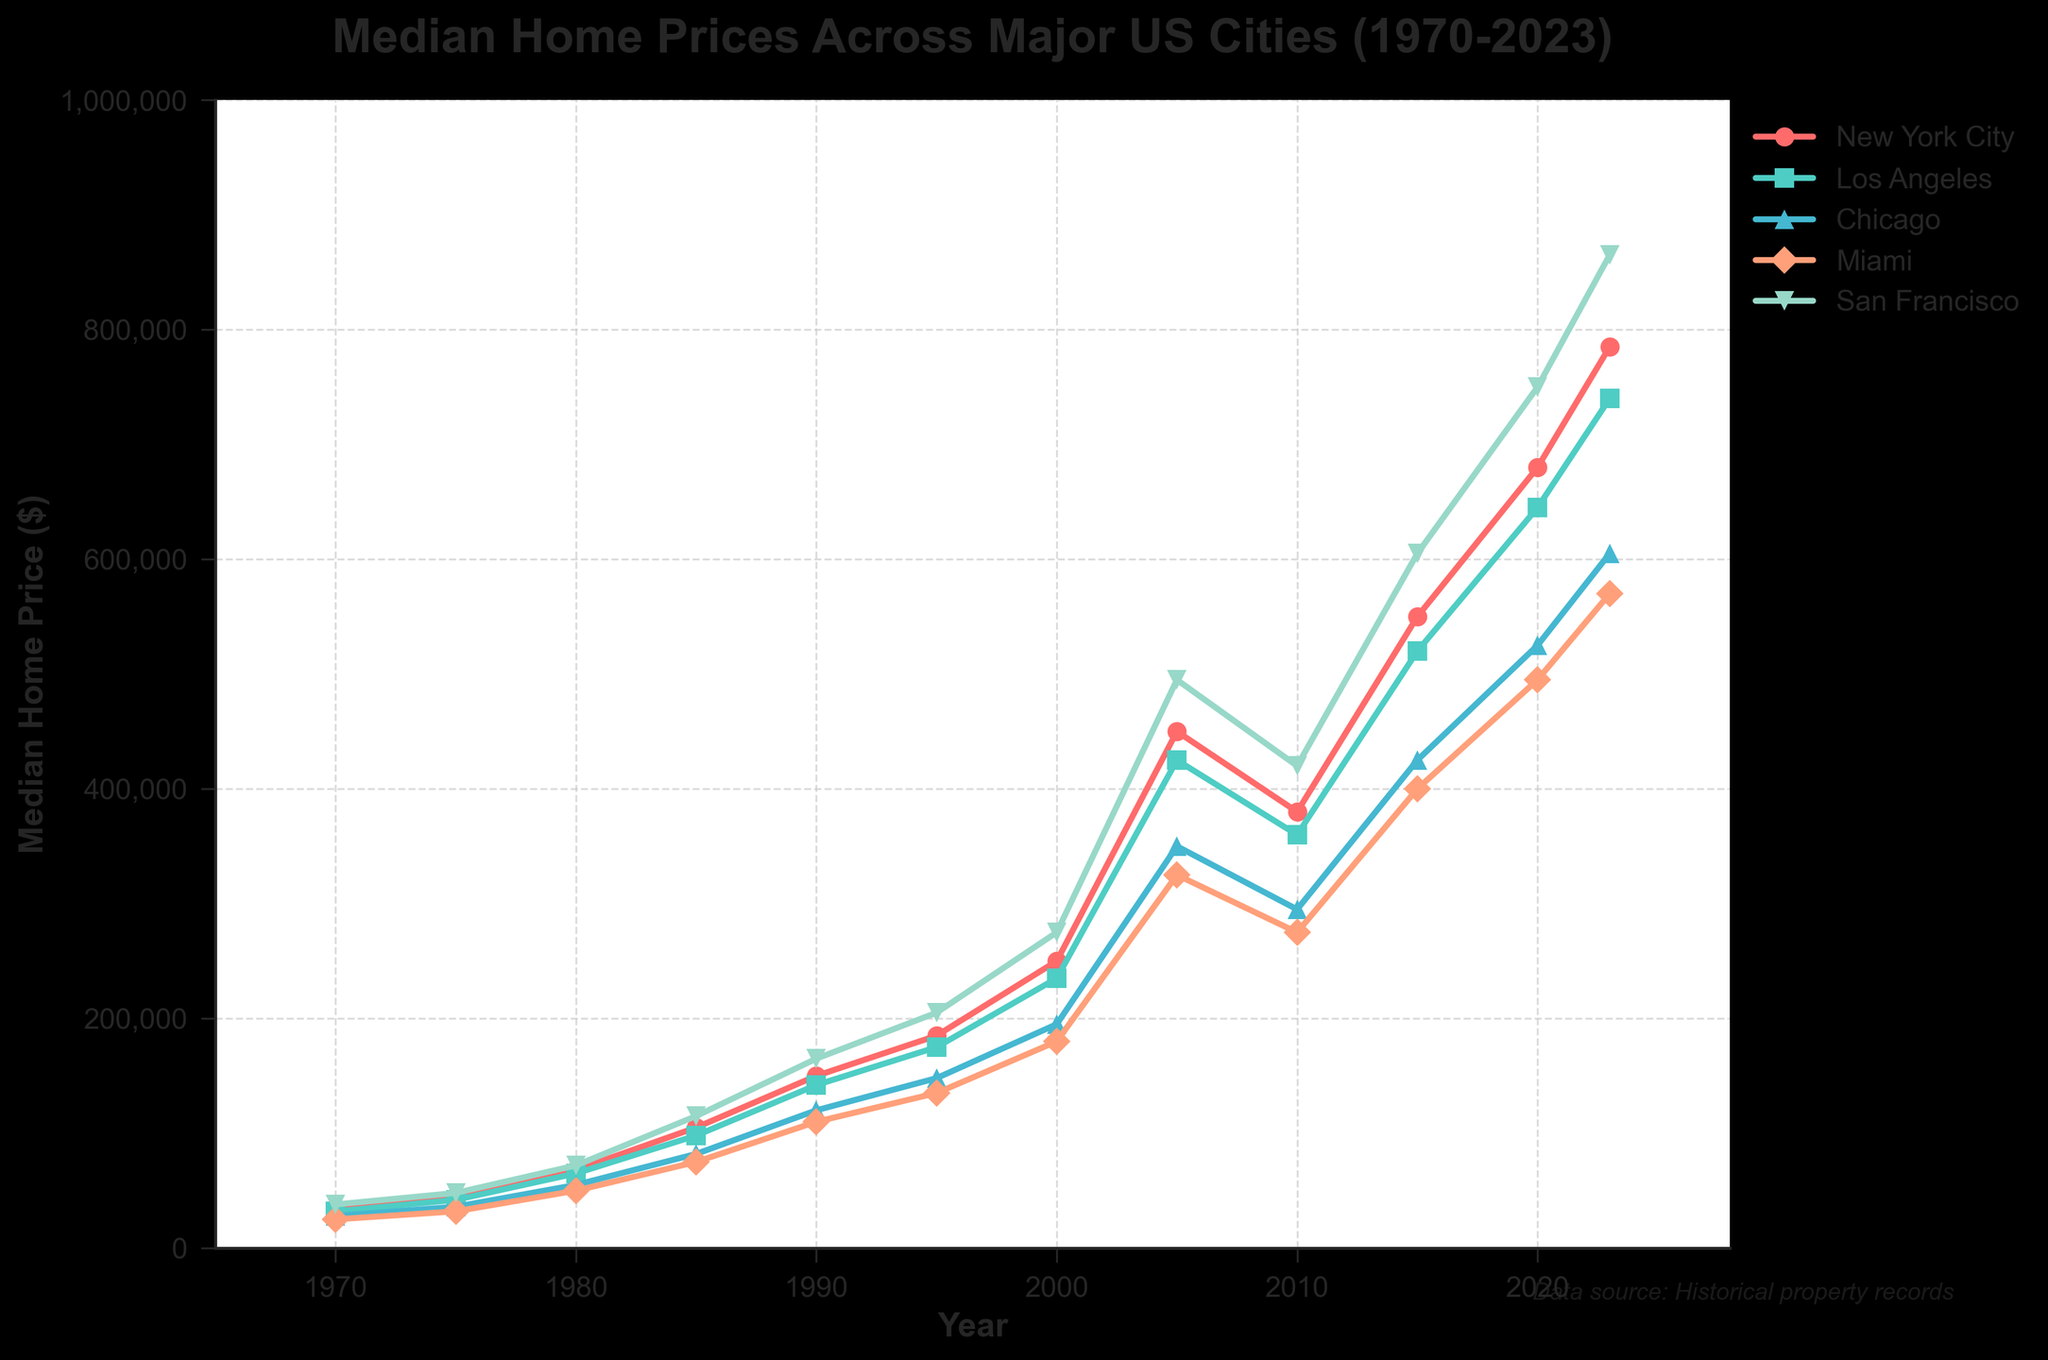Which city had the highest median home price in 2023? Look at the rightmost end of the lines in the graph corresponding to 2023. Identify the highest point among the lines. The highest point is for San Francisco.
Answer: San Francisco Which city showed the least increase in median home price from 1970 to 2023? Compare the growth in values from 1970 to 2023 for all cities. New York City increased from $35,000 to $785,000, Los Angeles from $32,000 to $740,000, Chicago from $28,000 to $605,000, Miami from $25,000 to $570,000, and San Francisco from $38,000 to $865,000. Chicago shows the least increase.
Answer: Chicago Which city had the steepest rise in home prices between 1985 and 1990? Compare the slopes of the lines between the years 1985 and 1990 for each city. The line with the steepest slope indicates the city with the steepest rise. Here, San Francisco had the steepest rise.
Answer: San Francisco What is the difference in median home prices between New York City and Miami in 2020? Identify the median home prices for New York City ($680,000) and Miami ($495,000) in 2020. Subtract the Miami value from the New York City value: $680,000 - $495,000 = $185,000.
Answer: $185,000 By how much did the median home price in Los Angeles increase from 2000 to 2023? Identify the values for Los Angeles in 2000 ($235,000) and 2023 ($740,000). Subtract the 2000 value from the 2023 value: $740,000 - $235,000 = $505,000.
Answer: $505,000 Which city had the lowest median home price in 1975, and what was it? Look at the lowest data point among all cities for the year 1975. The lowest point is for Miami, with a value of $32,000.
Answer: Miami, $32,000 What was the median home price of San Francisco in 2005 and how does it compare to New York City in the same year? Identify the home prices for San Francisco ($495,000) and New York City ($450,000) in 2005. Comparing these, San Francisco's median home price was higher.
Answer: San Francisco had a higher price in 2005 than New York City What was the average median home price across all cities in 2015? Identify the values for each city in 2015: New York City ($550,000), Los Angeles ($520,000), Chicago ($425,000), Miami ($400,000), and San Francisco ($605,000). Sum these values and divide by the number of cities: ($550,000 + $520,000 + $425,000 + $400,000 + $605,000) / 5 = $500,000.
Answer: $500,000 How did the median home price in Chicago change between 1990 and 2000? Look at the home prices for Chicago in 1990 ($120,000) and 2000 ($195,000). The change is $195,000 - $120,000 = $75,000.
Answer: Increased by $75,000 In which year did San Francisco first surpass the $500,000 median home price mark? Look at the progression of San Francisco's home prices and find the first year where the price exceeds $500,000. It first surpasses $500,000 in 2005.
Answer: 2005 